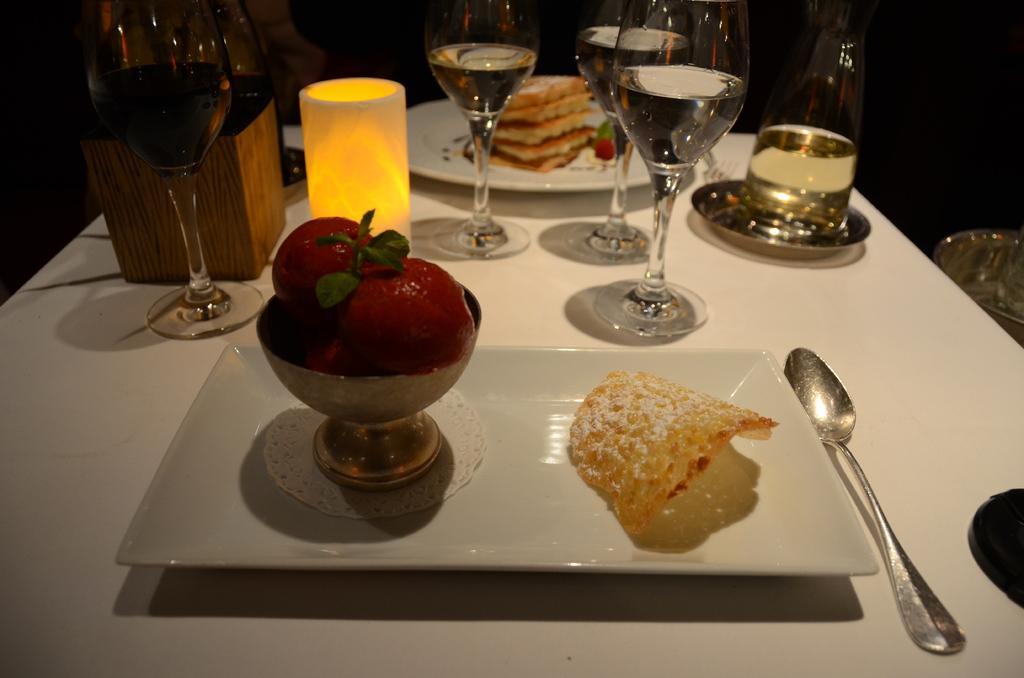Please provide a concise description of this image. There are some eatables and drinks on the table. 